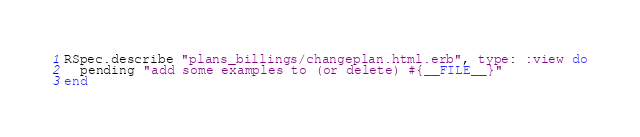<code> <loc_0><loc_0><loc_500><loc_500><_Ruby_>
RSpec.describe "plans_billings/changeplan.html.erb", type: :view do
  pending "add some examples to (or delete) #{__FILE__}"
end
</code> 